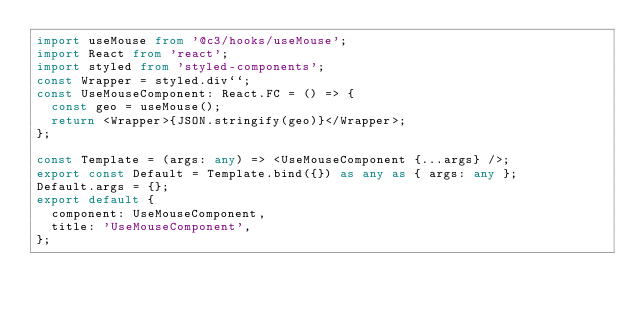<code> <loc_0><loc_0><loc_500><loc_500><_TypeScript_>import useMouse from '@c3/hooks/useMouse';
import React from 'react';
import styled from 'styled-components';
const Wrapper = styled.div``;
const UseMouseComponent: React.FC = () => {
  const geo = useMouse();
  return <Wrapper>{JSON.stringify(geo)}</Wrapper>;
};

const Template = (args: any) => <UseMouseComponent {...args} />;
export const Default = Template.bind({}) as any as { args: any };
Default.args = {};
export default {
  component: UseMouseComponent,
  title: 'UseMouseComponent',
};
</code> 